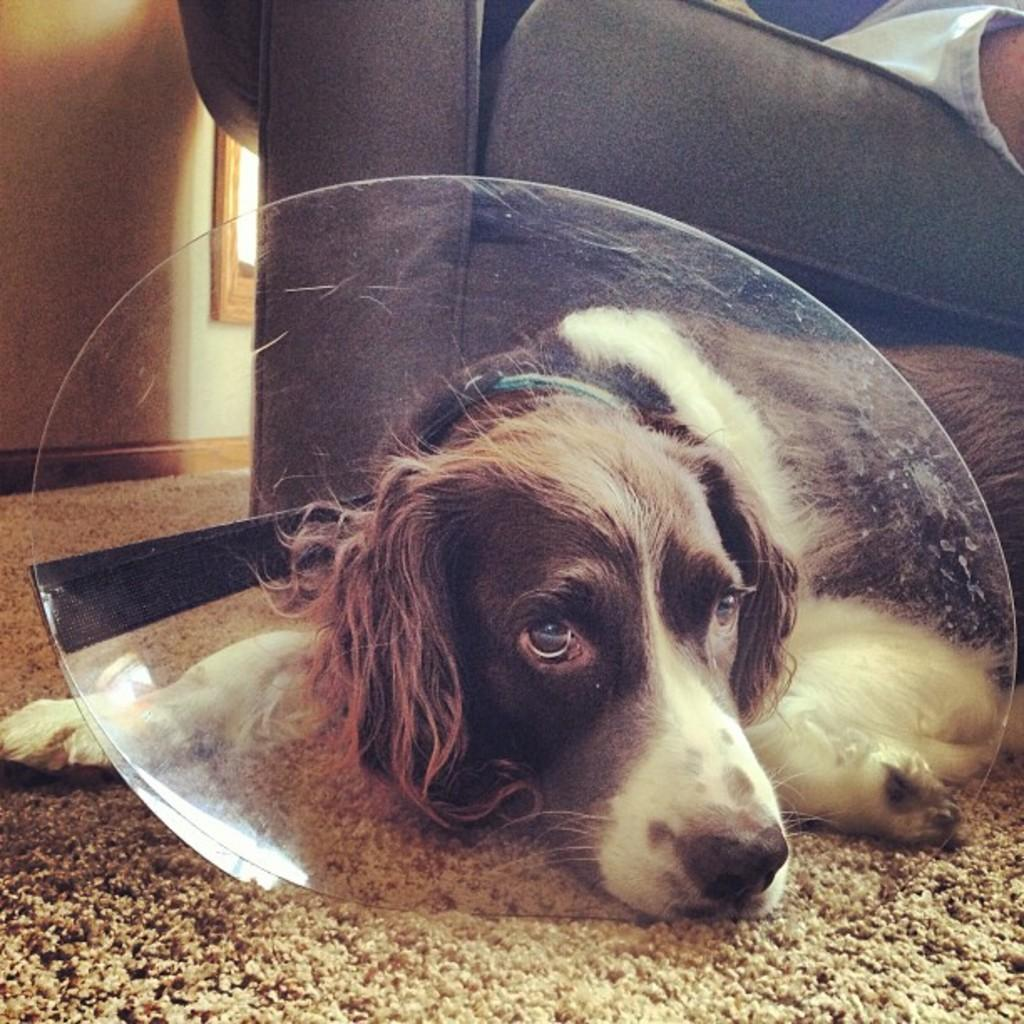What type of animal can be seen in the image? There is a dog in the image. What piece of furniture is visible at the top of the image? There is a couch at the top of the image. What type of structure is present in the top left of the image? There is a wall in the top left of the image. What type of fruit is the dog holding in the image? There is no fruit present in the image, and the dog is not holding anything. 